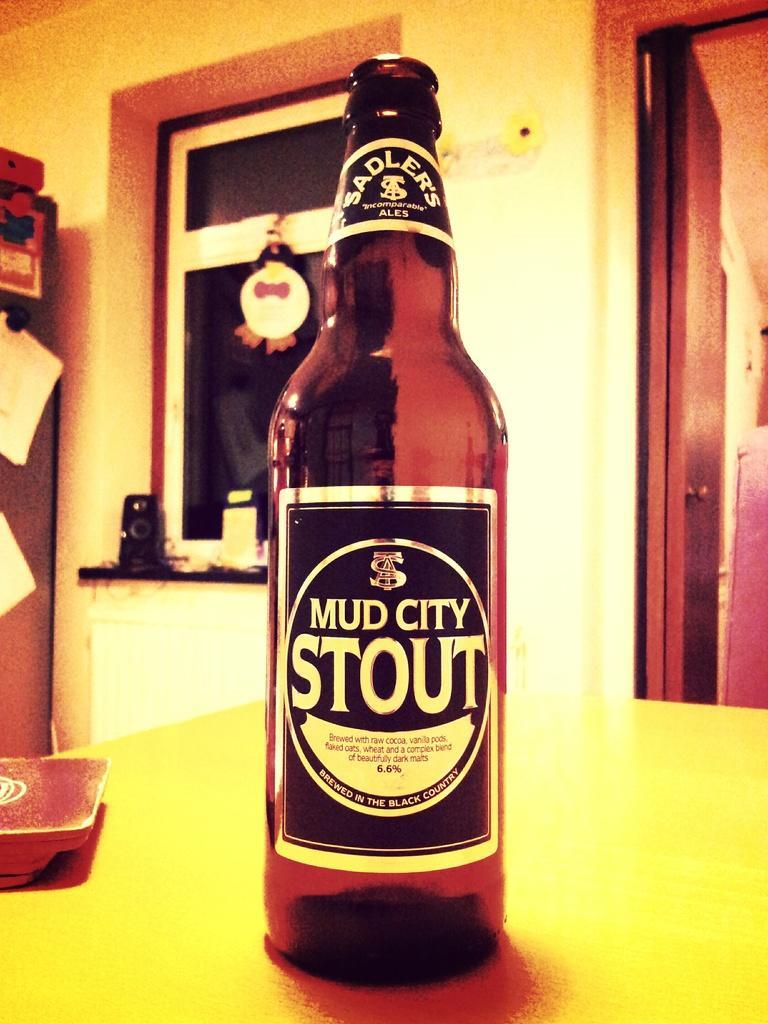Could you give a brief overview of what you see in this image? In this picture there is a wine bottle kept on the table and in the background of there is a door on the right side is a window on the left side with the speaker and the wall with some papers posted on pasted on it 